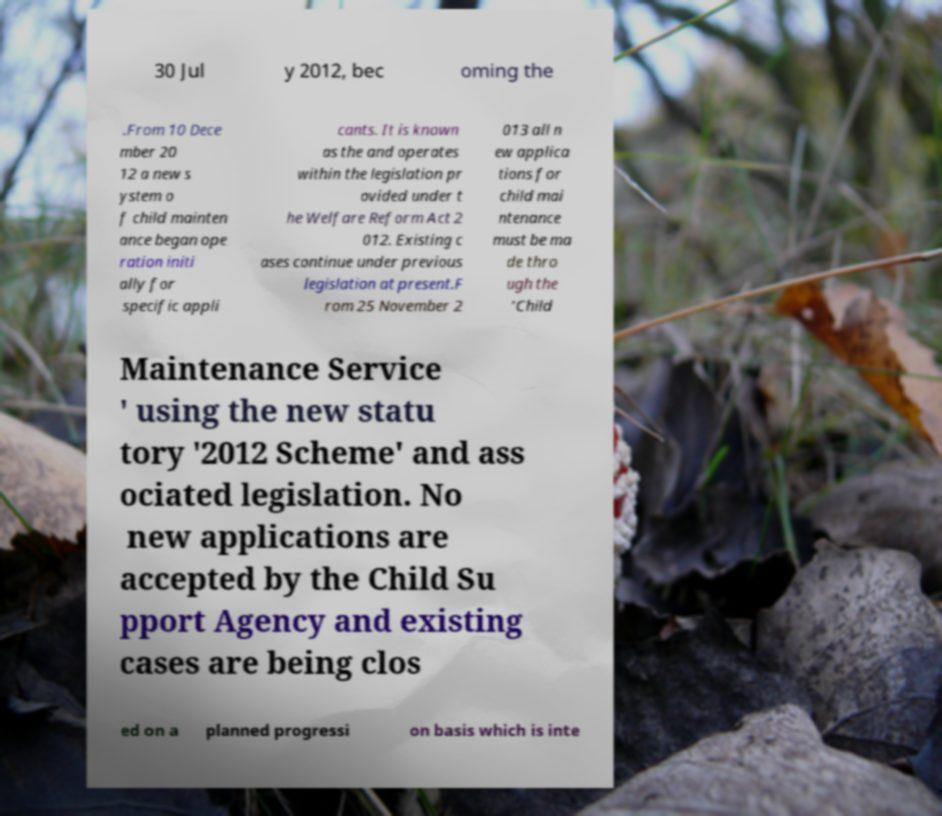Can you read and provide the text displayed in the image?This photo seems to have some interesting text. Can you extract and type it out for me? 30 Jul y 2012, bec oming the .From 10 Dece mber 20 12 a new s ystem o f child mainten ance began ope ration initi ally for specific appli cants. It is known as the and operates within the legislation pr ovided under t he Welfare Reform Act 2 012. Existing c ases continue under previous legislation at present.F rom 25 November 2 013 all n ew applica tions for child mai ntenance must be ma de thro ugh the 'Child Maintenance Service ' using the new statu tory '2012 Scheme' and ass ociated legislation. No new applications are accepted by the Child Su pport Agency and existing cases are being clos ed on a planned progressi on basis which is inte 